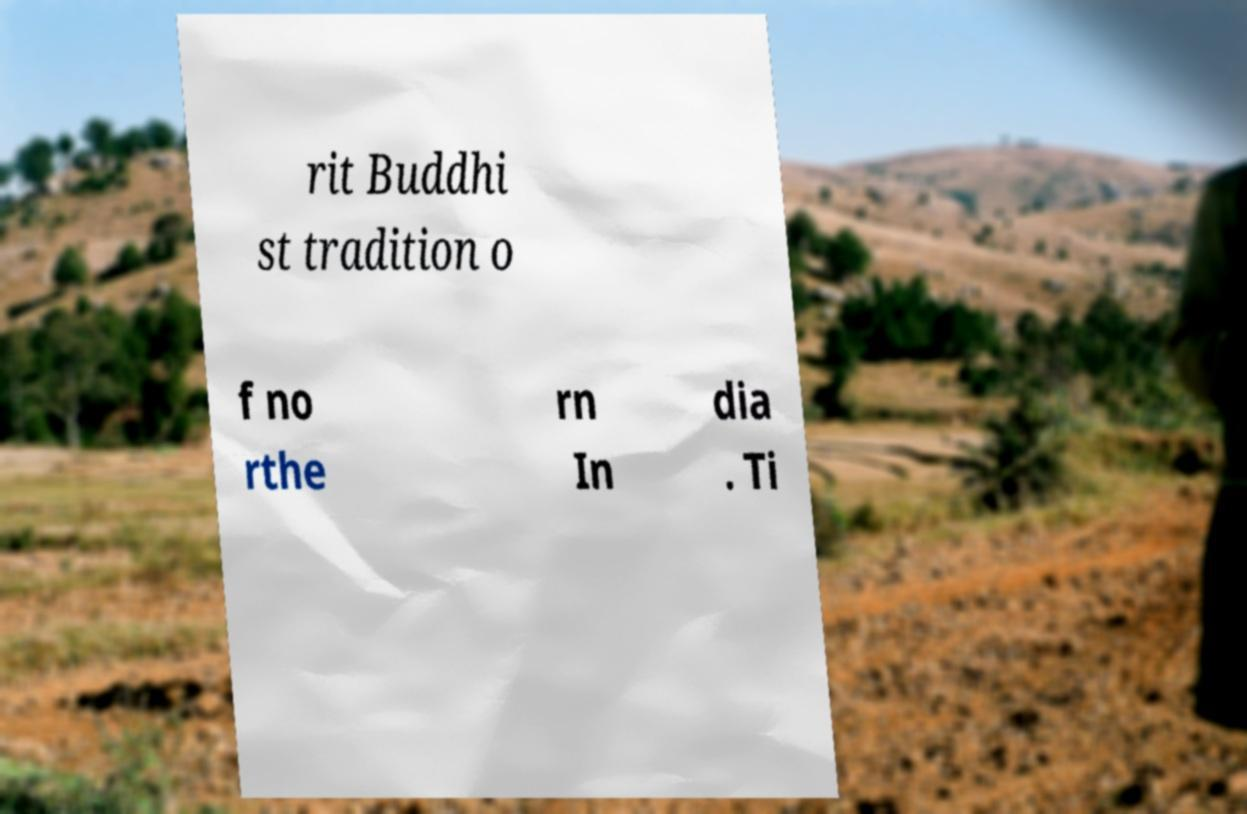For documentation purposes, I need the text within this image transcribed. Could you provide that? rit Buddhi st tradition o f no rthe rn In dia . Ti 